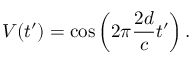Convert formula to latex. <formula><loc_0><loc_0><loc_500><loc_500>V ( t ^ { \prime } ) = \cos \left ( 2 \pi \frac { 2 d } { c } t ^ { \prime } \right ) .</formula> 